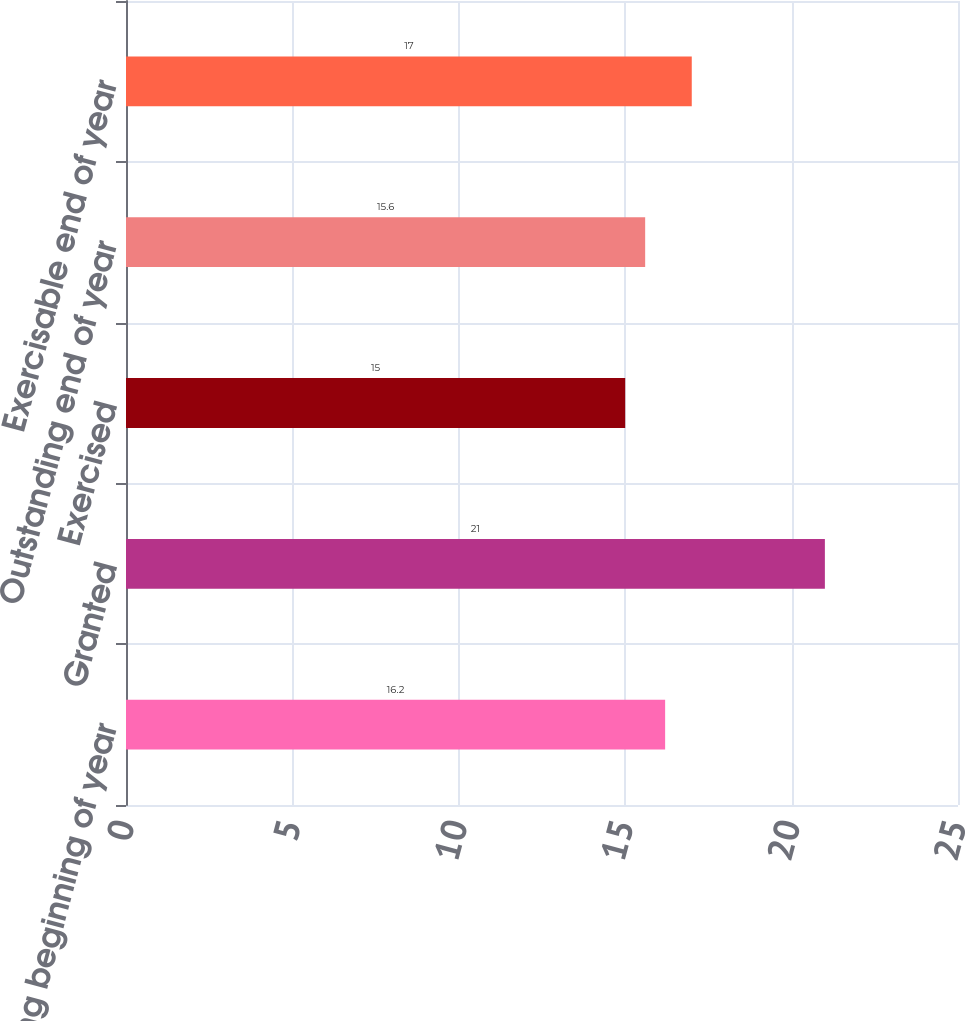Convert chart. <chart><loc_0><loc_0><loc_500><loc_500><bar_chart><fcel>Outstanding beginning of year<fcel>Granted<fcel>Exercised<fcel>Outstanding end of year<fcel>Exercisable end of year<nl><fcel>16.2<fcel>21<fcel>15<fcel>15.6<fcel>17<nl></chart> 